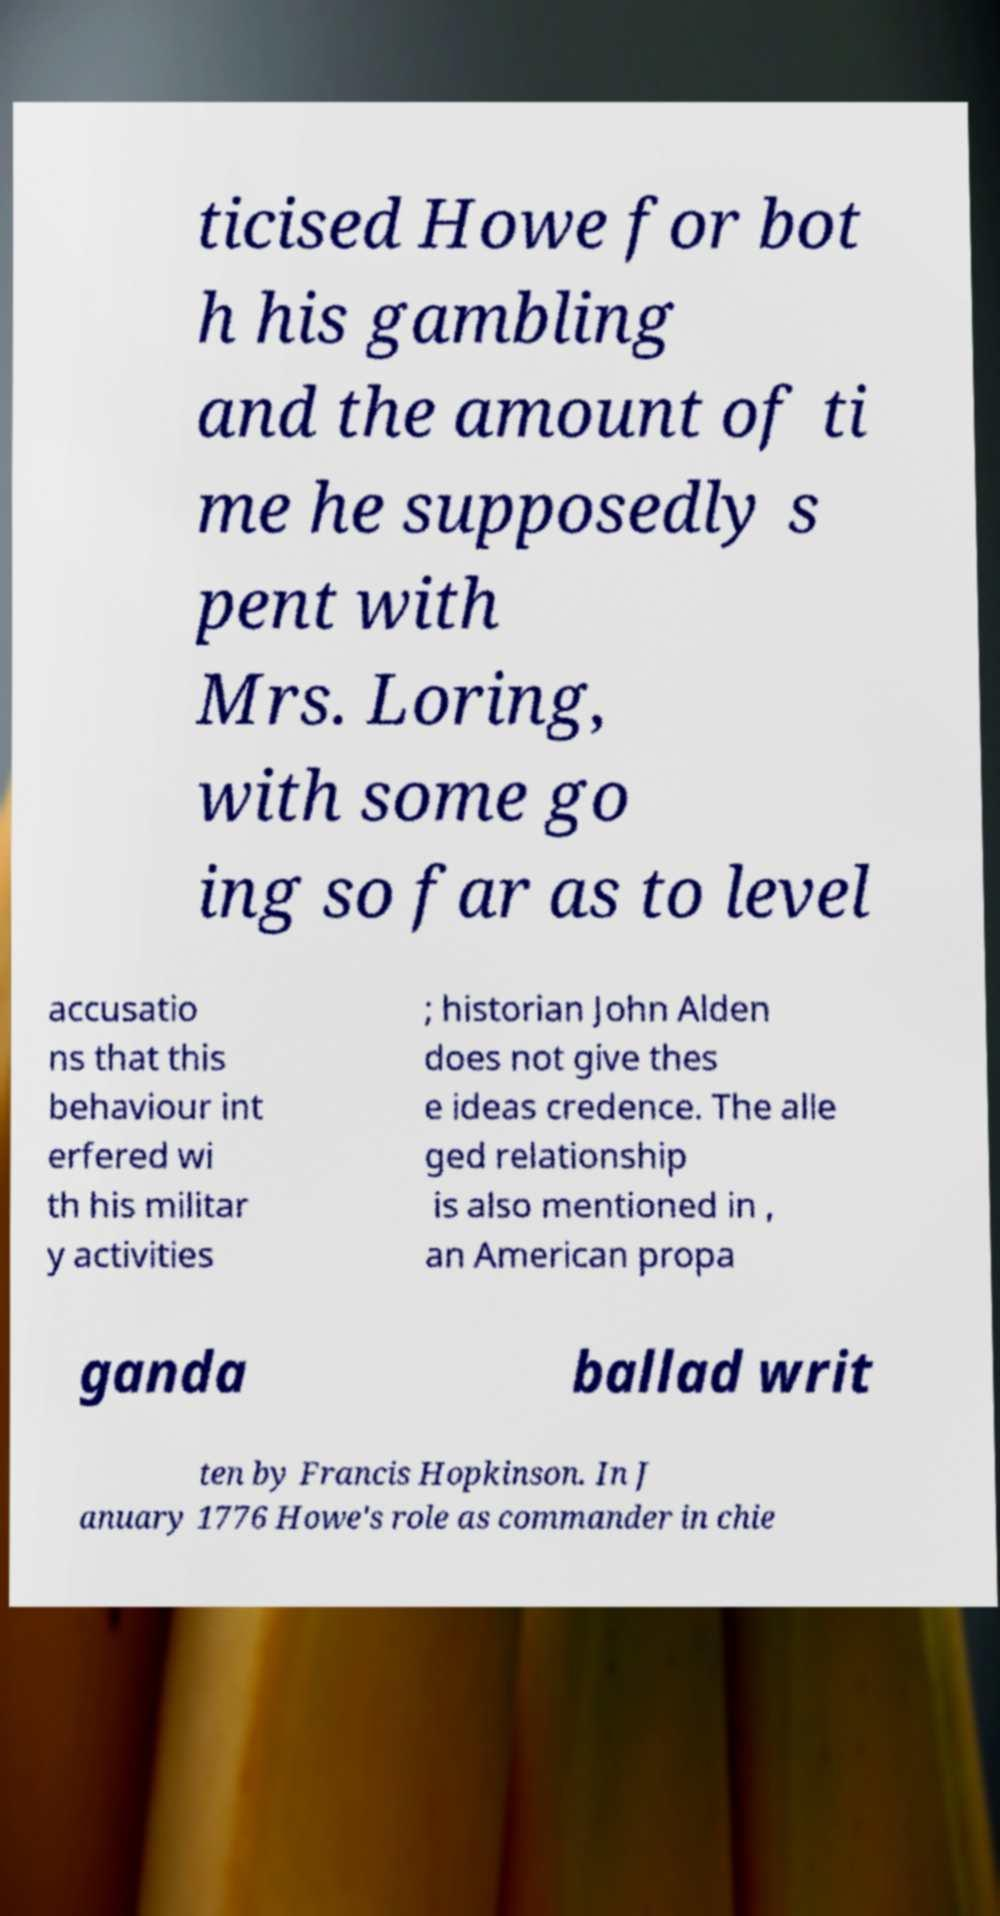I need the written content from this picture converted into text. Can you do that? ticised Howe for bot h his gambling and the amount of ti me he supposedly s pent with Mrs. Loring, with some go ing so far as to level accusatio ns that this behaviour int erfered wi th his militar y activities ; historian John Alden does not give thes e ideas credence. The alle ged relationship is also mentioned in , an American propa ganda ballad writ ten by Francis Hopkinson. In J anuary 1776 Howe's role as commander in chie 